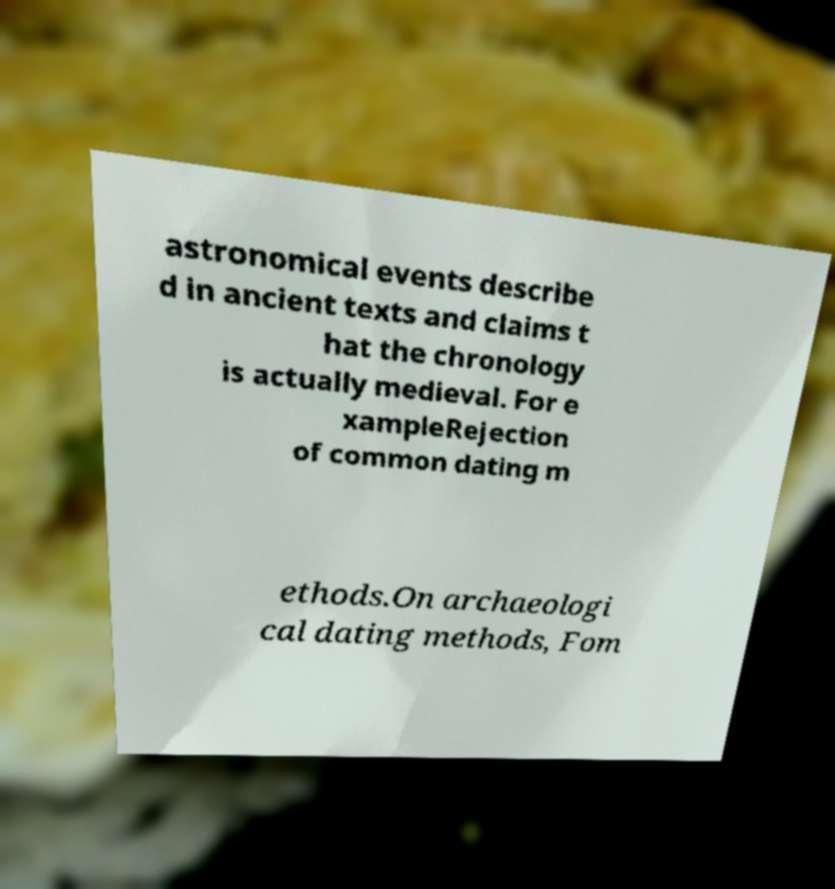Could you assist in decoding the text presented in this image and type it out clearly? astronomical events describe d in ancient texts and claims t hat the chronology is actually medieval. For e xampleRejection of common dating m ethods.On archaeologi cal dating methods, Fom 